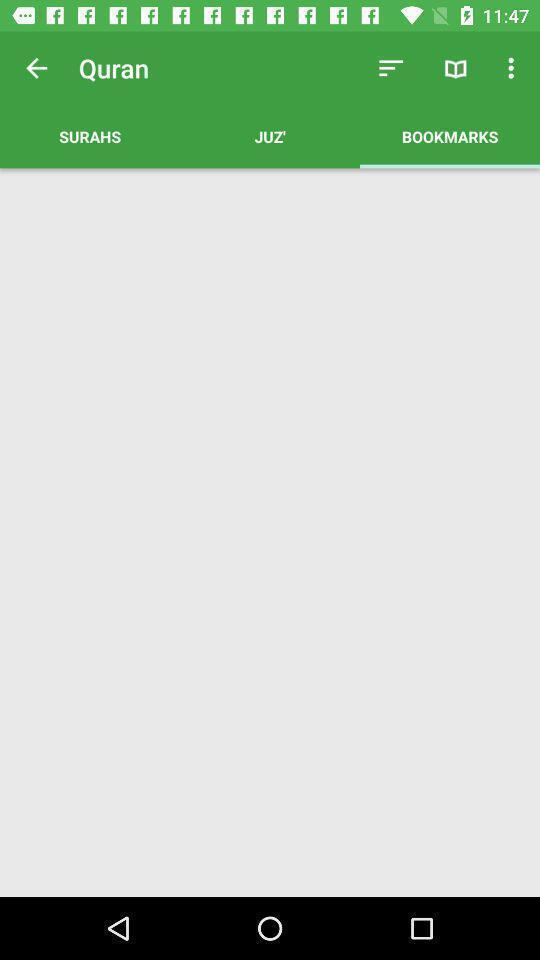Describe the visual elements of this screenshot. Screen shows multiple options in a reading app. 